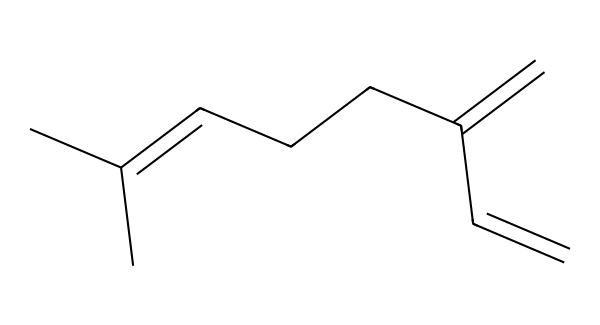What is the name of this terpene? The chemical structure provided corresponds to myrcene, which is a well-known terpene found in hops.
Answer: myrcene How many carbon atoms are present in myrcene? By examining the SMILES representation, we can count 10 carbon atoms in the structure, as each "C" represents a carbon in the backbone.
Answer: 10 What is the degree of unsaturation in myrcene? The degree of unsaturation can be calculated based on the number of double bonds in the structure. In myrcene, there are 3 double bonds, indicating a degree of unsaturation of 3.
Answer: 3 Is myrcene a cyclic or acyclic compound? The structure depicted does not form a ring; it is a linear configuration of carbon chains with multiple branches. Hence, it is acyclic.
Answer: acyclic What type of compound is myrcene classified as? Myrcene is classified under terpenes, which are a large class of organic compounds produced by various plants, particularly conifers and hops.
Answer: terpene How many double bonds are in the structure of myrcene? Upon analyzing the structure, it is clear that there are 3 double bonds indicated by the double bond notation in the SMILES representation.
Answer: 3 Does myrcene have any functional groups? The structure of myrcene lacks functional groups such as hydroxyl (-OH) or carbonyl (C=O) groups, indicating that it is primarily composed of hydrocarbons.
Answer: No 